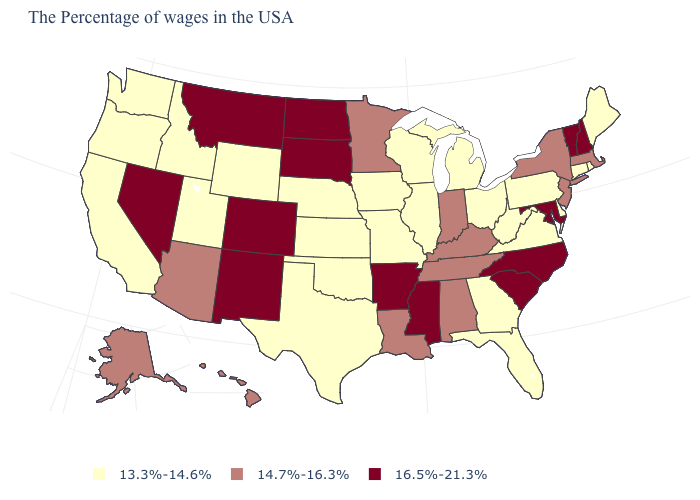What is the value of New Jersey?
Be succinct. 14.7%-16.3%. What is the value of Virginia?
Keep it brief. 13.3%-14.6%. What is the value of Michigan?
Short answer required. 13.3%-14.6%. Which states have the highest value in the USA?
Keep it brief. New Hampshire, Vermont, Maryland, North Carolina, South Carolina, Mississippi, Arkansas, South Dakota, North Dakota, Colorado, New Mexico, Montana, Nevada. Does Washington have the lowest value in the USA?
Concise answer only. Yes. Does Delaware have the lowest value in the South?
Answer briefly. Yes. What is the value of Oregon?
Be succinct. 13.3%-14.6%. Does Mississippi have a higher value than Texas?
Concise answer only. Yes. Name the states that have a value in the range 13.3%-14.6%?
Keep it brief. Maine, Rhode Island, Connecticut, Delaware, Pennsylvania, Virginia, West Virginia, Ohio, Florida, Georgia, Michigan, Wisconsin, Illinois, Missouri, Iowa, Kansas, Nebraska, Oklahoma, Texas, Wyoming, Utah, Idaho, California, Washington, Oregon. Does North Dakota have a higher value than Idaho?
Answer briefly. Yes. Name the states that have a value in the range 13.3%-14.6%?
Write a very short answer. Maine, Rhode Island, Connecticut, Delaware, Pennsylvania, Virginia, West Virginia, Ohio, Florida, Georgia, Michigan, Wisconsin, Illinois, Missouri, Iowa, Kansas, Nebraska, Oklahoma, Texas, Wyoming, Utah, Idaho, California, Washington, Oregon. What is the value of Nevada?
Concise answer only. 16.5%-21.3%. What is the highest value in states that border Arizona?
Answer briefly. 16.5%-21.3%. Name the states that have a value in the range 13.3%-14.6%?
Answer briefly. Maine, Rhode Island, Connecticut, Delaware, Pennsylvania, Virginia, West Virginia, Ohio, Florida, Georgia, Michigan, Wisconsin, Illinois, Missouri, Iowa, Kansas, Nebraska, Oklahoma, Texas, Wyoming, Utah, Idaho, California, Washington, Oregon. Does Hawaii have the highest value in the West?
Write a very short answer. No. 